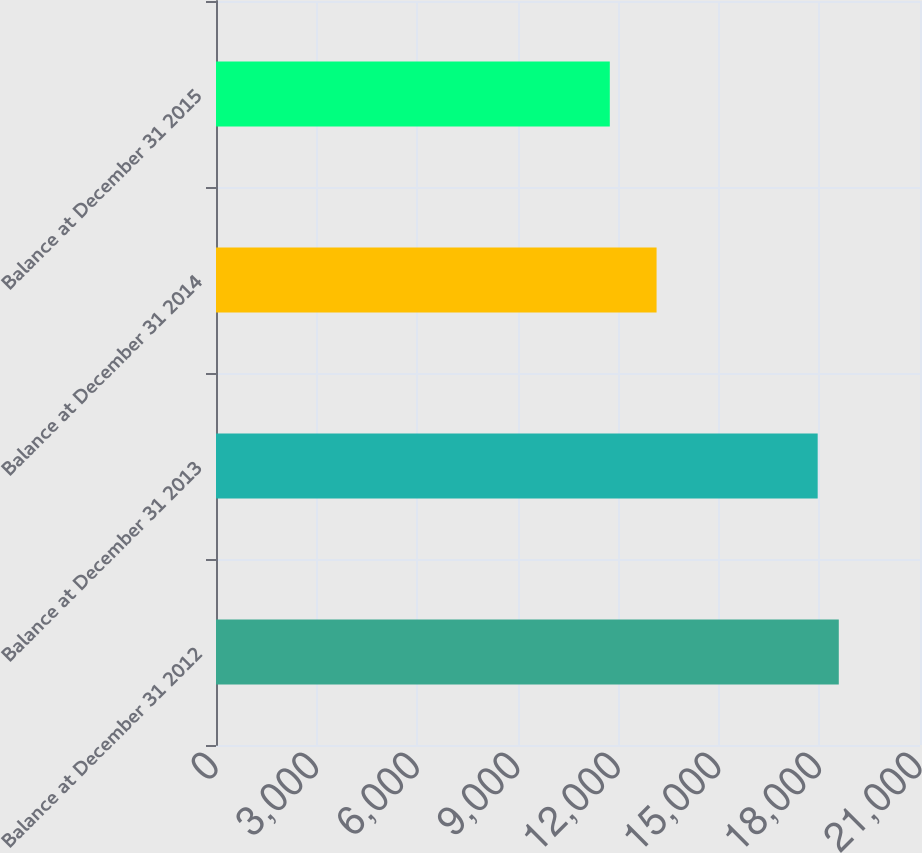Convert chart. <chart><loc_0><loc_0><loc_500><loc_500><bar_chart><fcel>Balance at December 31 2012<fcel>Balance at December 31 2013<fcel>Balance at December 31 2014<fcel>Balance at December 31 2015<nl><fcel>18577.3<fcel>17948<fcel>13142<fcel>11747<nl></chart> 